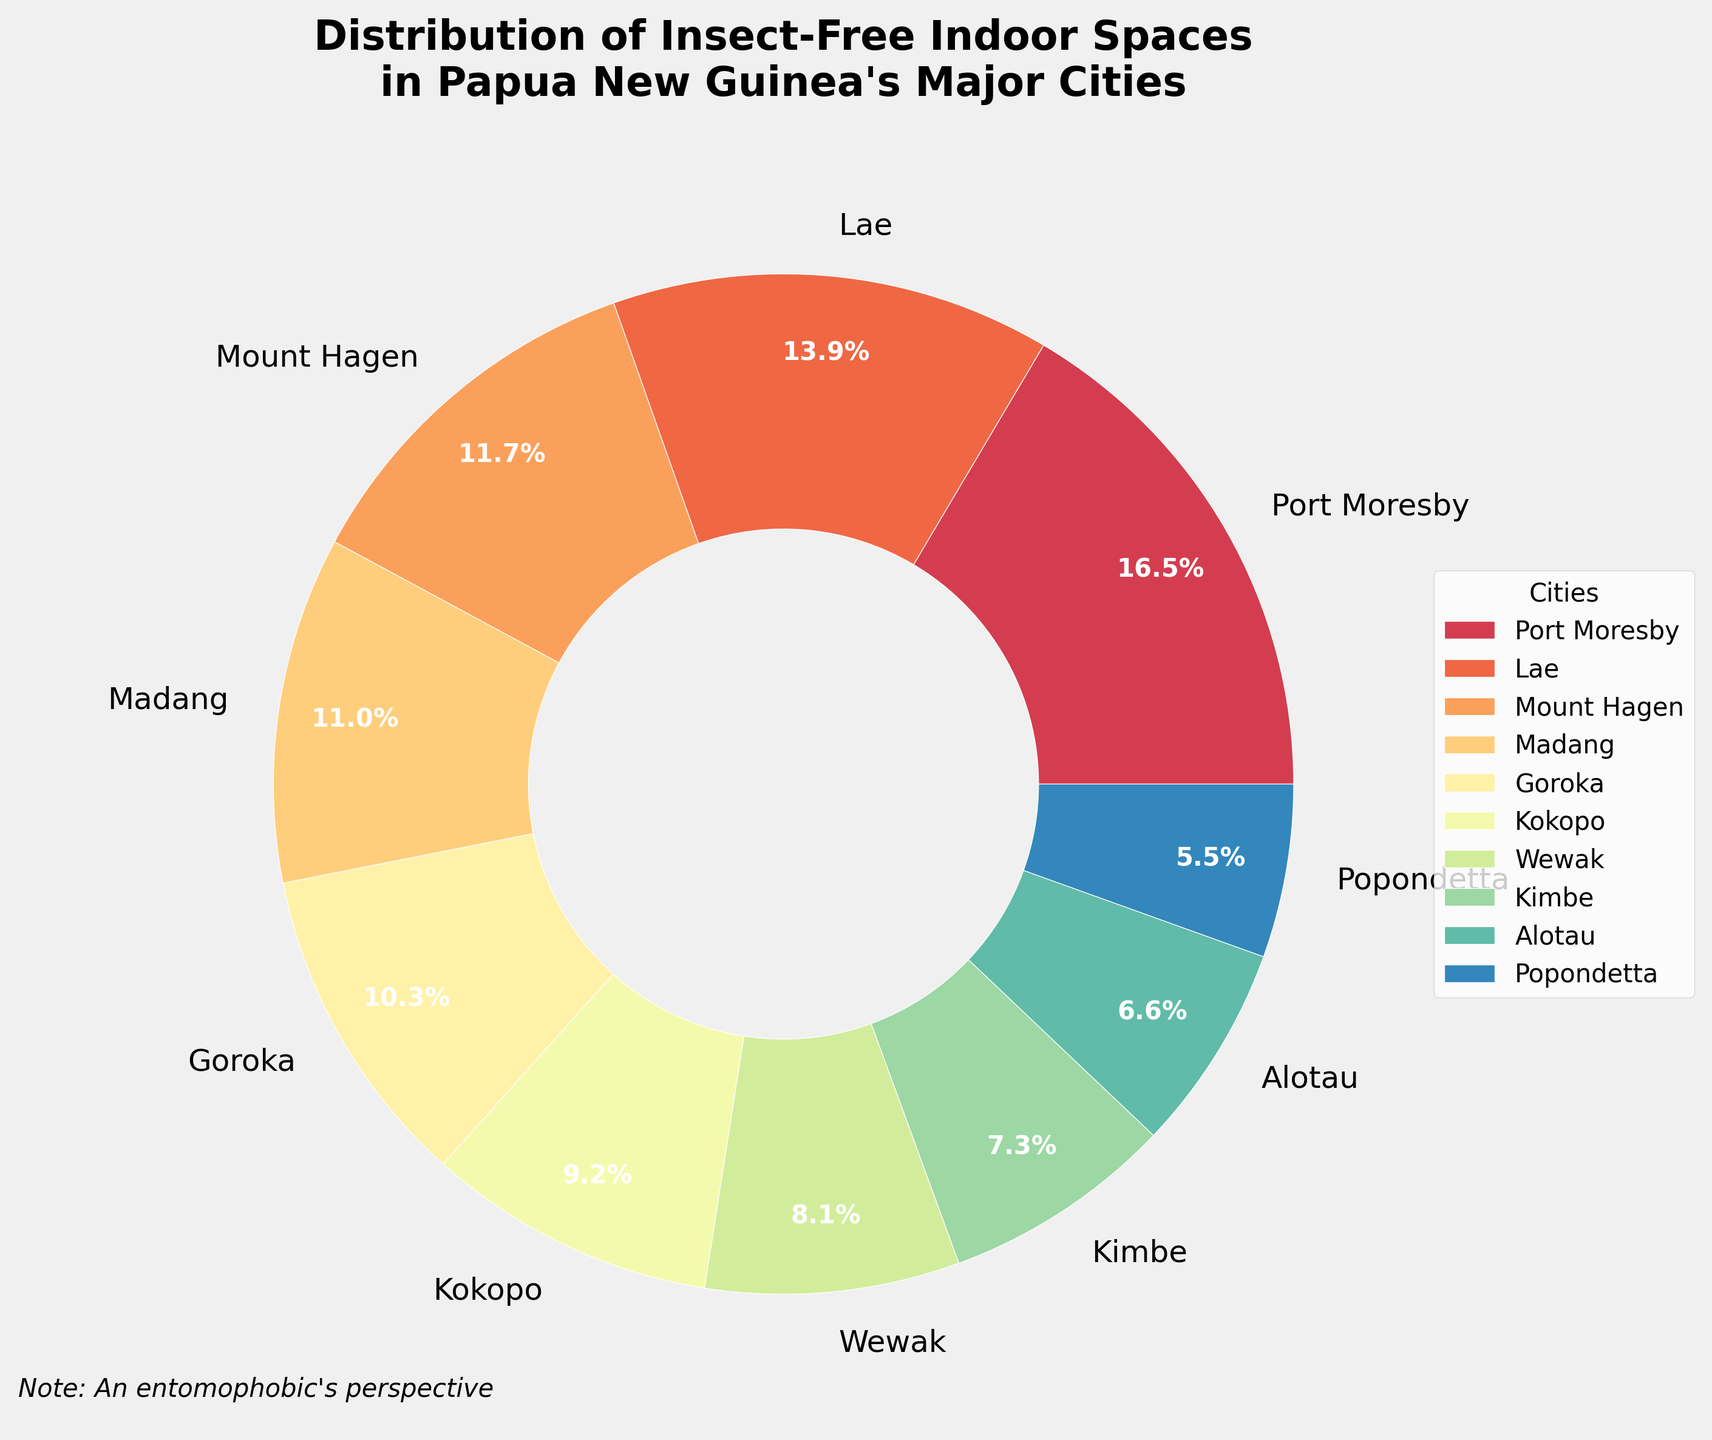How many cities have less than 25% insect-free indoor spaces? First, identify the cities with percentages less than 25%. These are Wewak (22%), Kimbe (20%), Alotau (18%), and Popondetta (15%). Count these cities.
Answer: 4 Which city has the highest percentage of insect-free indoor spaces? Look at the percentages and find the highest value. Port Moresby has the highest percentage at 45%.
Answer: Port Moresby What is the combined percentage of insect-free indoor spaces in Lae and Mount Hagen? Add the percentages for Lae (38%) and Mount Hagen (32%): 38 + 32 = 70.
Answer: 70% How many cities have a percentage of insect-free indoor spaces between 20% and 30%? Identify the cities within this range: Madang (30%), Goroka (28%), and Kokopo (25%). Count these cities.
Answer: 3 Which city has the smallest percentage of insect-free indoor spaces, and what is that percentage? Find the smallest percentage, which is 15%. The city is Popondetta.
Answer: Popondetta, 15% What is the percentage difference between the city with the highest and the lowest insect-free indoor spaces? Subtract the smallest percentage (Popondetta, 15%) from the largest percentage (Port Moresby, 45%): 45 - 15 = 30.
Answer: 30% Which cities have over 30% insect-free indoor spaces? Identify the cities with percentages greater than 30%: Port Moresby (45%), Lae (38%), and Mount Hagen (32%).
Answer: Port Moresby, Lae, Mount Hagen What is the median percentage of insect-free indoor spaces among all the cities? First, list the percentages in order: 15, 18, 20, 22, 25, 28, 30, 32, 38, 45. The middle two numbers are 25 and 28. Calculate the average: (25+28)/2 = 26.5.
Answer: 26.5% Is the percentage of insect-free indoor spaces in Madang higher than in Lae? Compare the percentages: Madang (30%) and Lae (38%). Madang's percentage is lower.
Answer: No 